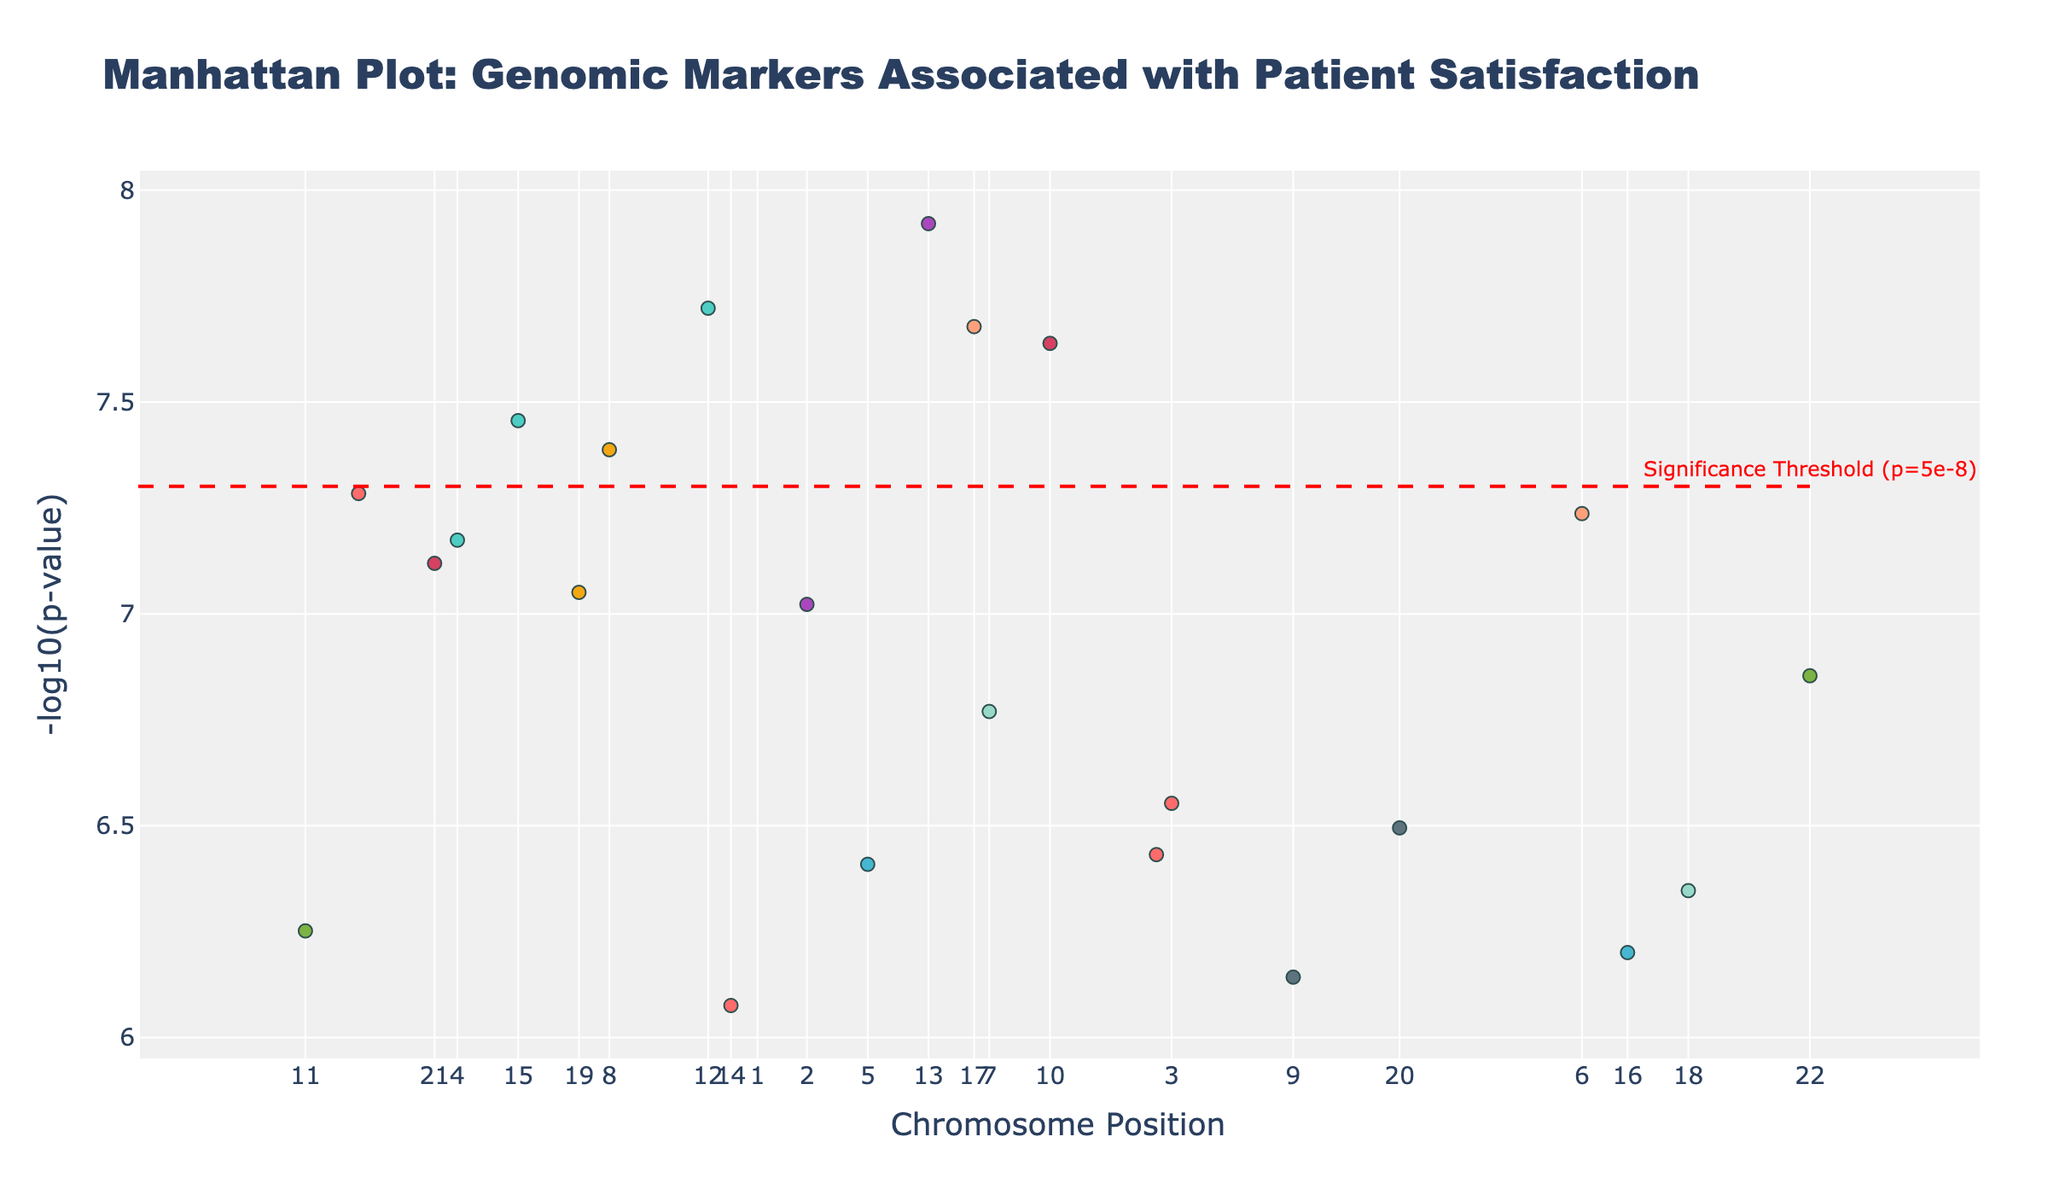What's the title of the plot? The title of the plot can be found at the top of the figure. It is usually designed to give an overview of the visualized data.
Answer: Manhattan Plot: Genomic Markers Associated with Patient Satisfaction How many chromosomes are represented in the plot? Count the number of unique chromosome labels on the x-axis. Since each chromosome has its label, you can sum them up to get the total number of chromosomes displayed.
Answer: 22 Which SNP has the highest -log10(p-value)? Inspect the dots in the plot to find the highest point on the y-axis, which represents the highest -log10(p-value). Hover over this point to see the SNP label.
Answer: rs6759892 What color is used to represent the markers for Chromosome 1? Look at the colors used for the dots corresponding to Chromosome 1 in the plot legend or directly in the visual representation.
Answer: Light Red Which department is associated with the SNP rs4994? Use the hover-over feature in the plot to find the SNP rs4994 and check the displayed information, which includes the associated department.
Answer: Dermatology How many SNPs have a p-value smaller than the significance threshold (5e-8)? Identify the horizontal red dashed line indicating the significance threshold. Count the dots above this line to determine how many SNPs have p-values smaller than 5e-8.
Answer: 9 Which chromosome has the SNP with the smallest p-value? Identify the SNP with the highest -log10(p) on the y-axis. This represents the smallest p-value and check its chromosome label on the x-axis.
Answer: Chromosome 2 Which department has the second most significant SNP marker? First, find the SNP with the highest -log10(p) to identify the most significant marker. Then, find the next highest -log10(p) value and check the associated department using the hover-over information.
Answer: Intensive Care What is the -log10(p-value) for rs1045642? Locate the SNP rs1045642 in the plot by using the hover-over information on the corresponding dot to see its -log10(p) value.
Answer: Approximately 6.55 How does the significance threshold relate to the p-values of SNPs in Psychiatry? Identify the SNP(s) associated with Psychiatry by using the hover feature and compare their -log10(p) values to the significance threshold line (-log10(5e-8)).
Answer: Slightly above significance threshold 